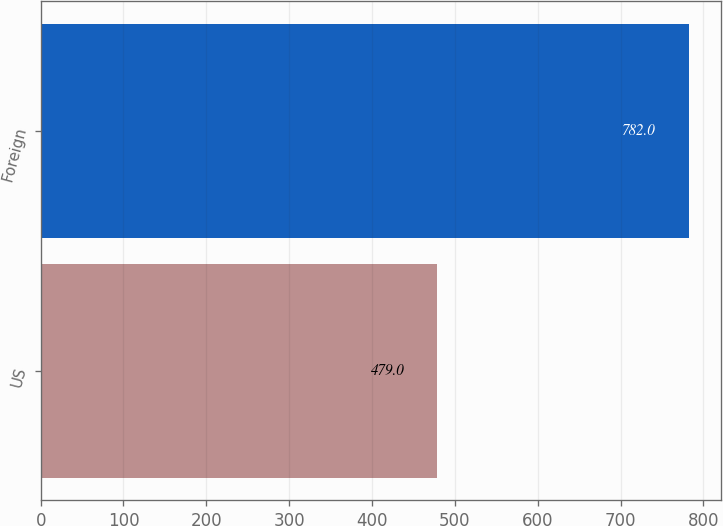Convert chart to OTSL. <chart><loc_0><loc_0><loc_500><loc_500><bar_chart><fcel>US<fcel>Foreign<nl><fcel>479<fcel>782<nl></chart> 